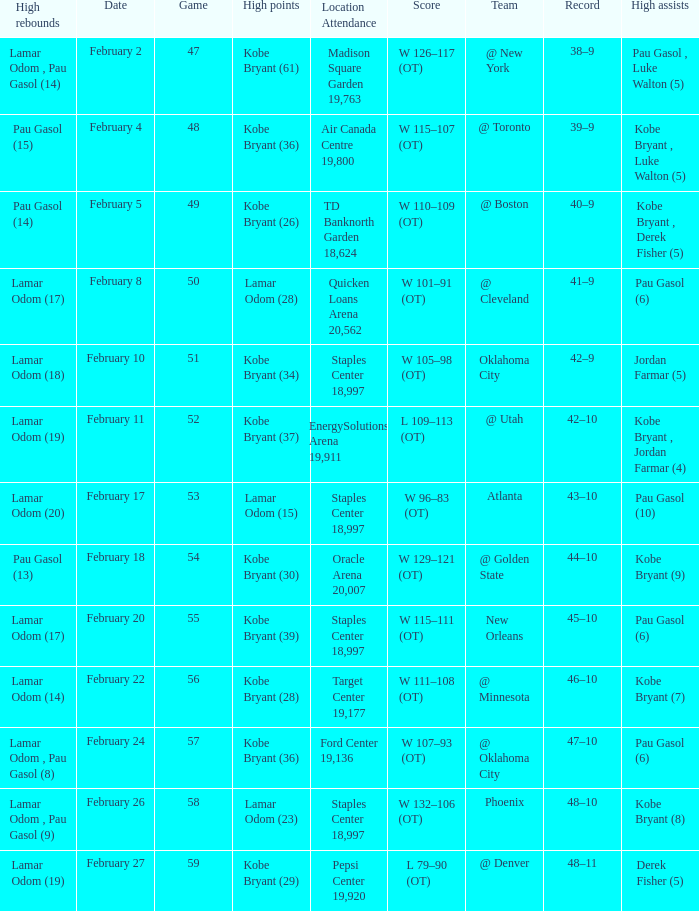Who had the most assists in the game against Atlanta? Pau Gasol (10). 